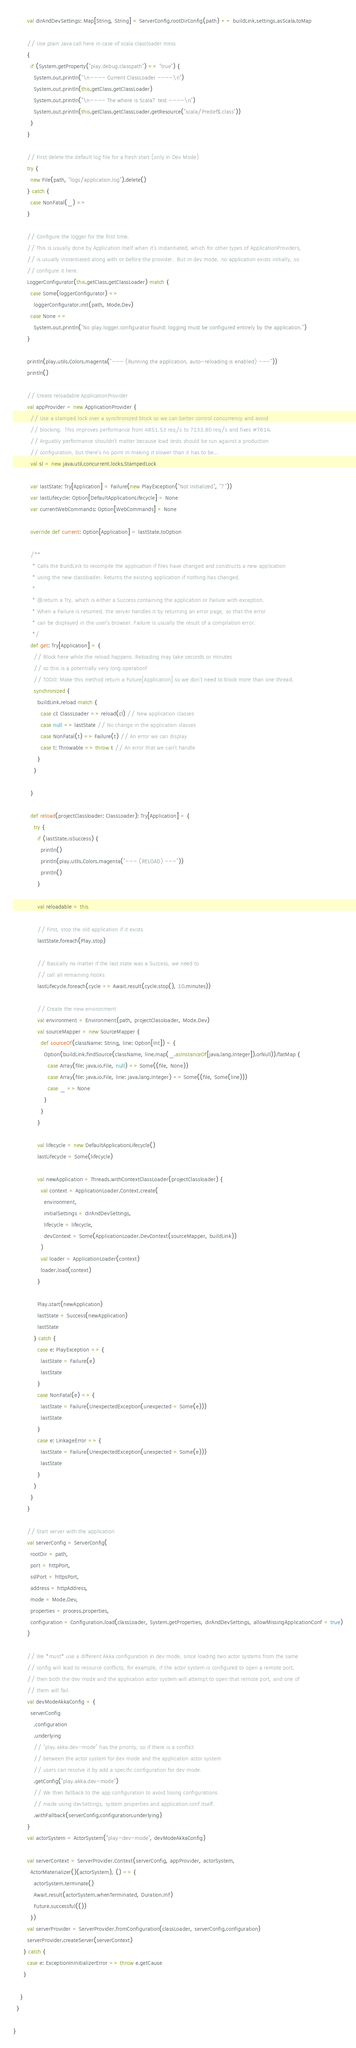<code> <loc_0><loc_0><loc_500><loc_500><_Scala_>
        val dirAndDevSettings: Map[String, String] = ServerConfig.rootDirConfig(path) ++ buildLink.settings.asScala.toMap

        // Use plain Java call here in case of scala classloader mess
        {
          if (System.getProperty("play.debug.classpath") == "true") {
            System.out.println("\n---- Current ClassLoader ----\n")
            System.out.println(this.getClass.getClassLoader)
            System.out.println("\n---- The where is Scala? test ----\n")
            System.out.println(this.getClass.getClassLoader.getResource("scala/Predef$.class"))
          }
        }

        // First delete the default log file for a fresh start (only in Dev Mode)
        try {
          new File(path, "logs/application.log").delete()
        } catch {
          case NonFatal(_) =>
        }

        // Configure the logger for the first time.
        // This is usually done by Application itself when it's instantiated, which for other types of ApplicationProviders,
        // is usually instantiated along with or before the provider.  But in dev mode, no application exists initially, so
        // configure it here.
        LoggerConfigurator(this.getClass.getClassLoader) match {
          case Some(loggerConfigurator) =>
            loggerConfigurator.init(path, Mode.Dev)
          case None =>
            System.out.println("No play.logger.configurator found: logging must be configured entirely by the application.")
        }

        println(play.utils.Colors.magenta("--- (Running the application, auto-reloading is enabled) ---"))
        println()

        // Create reloadable ApplicationProvider
        val appProvider = new ApplicationProvider {
          // Use a stamped lock over a synchronized block so we can better control concurrency and avoid
          // blocking.  This improves performance from 4851.53 req/s to 7133.80 req/s and fixes #7614.
          // Arguably performance shouldn't matter because load tests should be run against a production
          // configuration, but there's no point in making it slower than it has to be...
          val sl = new java.util.concurrent.locks.StampedLock

          var lastState: Try[Application] = Failure(new PlayException("Not initialized", "?"))
          var lastLifecycle: Option[DefaultApplicationLifecycle] = None
          var currentWebCommands: Option[WebCommands] = None

          override def current: Option[Application] = lastState.toOption

          /**
           * Calls the BuildLink to recompile the application if files have changed and constructs a new application
           * using the new classloader. Returns the existing application if nothing has changed.
           *
           * @return a Try, which is either a Success containing the application or Failure with exception.
           * When a Failure is returned, the server handles it by returning an error page, so that the error
           * can be displayed in the user's browser. Failure is usually the result of a compilation error.
           */
          def get: Try[Application] = {
            // Block here while the reload happens. Reloading may take seconds or minutes
            // so this is a potentially very long operation!
            // TODO: Make this method return a Future[Application] so we don't need to block more than one thread.
            synchronized {
              buildLink.reload match {
                case cl: ClassLoader => reload(cl) // New application classes
                case null => lastState // No change in the application classes
                case NonFatal(t) => Failure(t) // An error we can display
                case t: Throwable => throw t // An error that we can't handle
              }
            }

          }

          def reload(projectClassloader: ClassLoader): Try[Application] = {
            try {
              if (lastState.isSuccess) {
                println()
                println(play.utils.Colors.magenta("--- (RELOAD) ---"))
                println()
              }

              val reloadable = this

              // First, stop the old application if it exists
              lastState.foreach(Play.stop)

              // Basically no matter if the last state was a Success, we need to
              // call all remaining hooks
              lastLifecycle.foreach(cycle => Await.result(cycle.stop(), 10.minutes))

              // Create the new environment
              val environment = Environment(path, projectClassloader, Mode.Dev)
              val sourceMapper = new SourceMapper {
                def sourceOf(className: String, line: Option[Int]) = {
                  Option(buildLink.findSource(className, line.map(_.asInstanceOf[java.lang.Integer]).orNull)).flatMap {
                    case Array(file: java.io.File, null) => Some((file, None))
                    case Array(file: java.io.File, line: java.lang.Integer) => Some((file, Some(line)))
                    case _ => None
                  }
                }
              }

              val lifecycle = new DefaultApplicationLifecycle()
              lastLifecycle = Some(lifecycle)

              val newApplication = Threads.withContextClassLoader(projectClassloader) {
                val context = ApplicationLoader.Context.create(
                  environment,
                  initialSettings = dirAndDevSettings,
                  lifecycle = lifecycle,
                  devContext = Some(ApplicationLoader.DevContext(sourceMapper, buildLink))
                )
                val loader = ApplicationLoader(context)
                loader.load(context)
              }

              Play.start(newApplication)
              lastState = Success(newApplication)
              lastState
            } catch {
              case e: PlayException => {
                lastState = Failure(e)
                lastState
              }
              case NonFatal(e) => {
                lastState = Failure(UnexpectedException(unexpected = Some(e)))
                lastState
              }
              case e: LinkageError => {
                lastState = Failure(UnexpectedException(unexpected = Some(e)))
                lastState
              }
            }
          }
        }

        // Start server with the application
        val serverConfig = ServerConfig(
          rootDir = path,
          port = httpPort,
          sslPort = httpsPort,
          address = httpAddress,
          mode = Mode.Dev,
          properties = process.properties,
          configuration = Configuration.load(classLoader, System.getProperties, dirAndDevSettings, allowMissingApplicationConf = true)
        )

        // We *must* use a different Akka configuration in dev mode, since loading two actor systems from the same
        // config will lead to resource conflicts, for example, if the actor system is configured to open a remote port,
        // then both the dev mode and the application actor system will attempt to open that remote port, and one of
        // them will fail.
        val devModeAkkaConfig = {
          serverConfig
            .configuration
            .underlying
            // "play.akka.dev-mode" has the priority, so if there is a conflict
            // between the actor system for dev mode and the application actor system
            // users can resolve it by add a specific configuration for dev mode.
            .getConfig("play.akka.dev-mode")
            // We then fallback to the app configuration to avoid losing configurations
            // made using devSettings, system properties and application.conf itself.
            .withFallback(serverConfig.configuration.underlying)
        }
        val actorSystem = ActorSystem("play-dev-mode", devModeAkkaConfig)

        val serverContext = ServerProvider.Context(serverConfig, appProvider, actorSystem,
          ActorMaterializer()(actorSystem), () => {
            actorSystem.terminate()
            Await.result(actorSystem.whenTerminated, Duration.Inf)
            Future.successful(())
          })
        val serverProvider = ServerProvider.fromConfiguration(classLoader, serverConfig.configuration)
        serverProvider.createServer(serverContext)
      } catch {
        case e: ExceptionInInitializerError => throw e.getCause
      }

    }
  }

}
</code> 